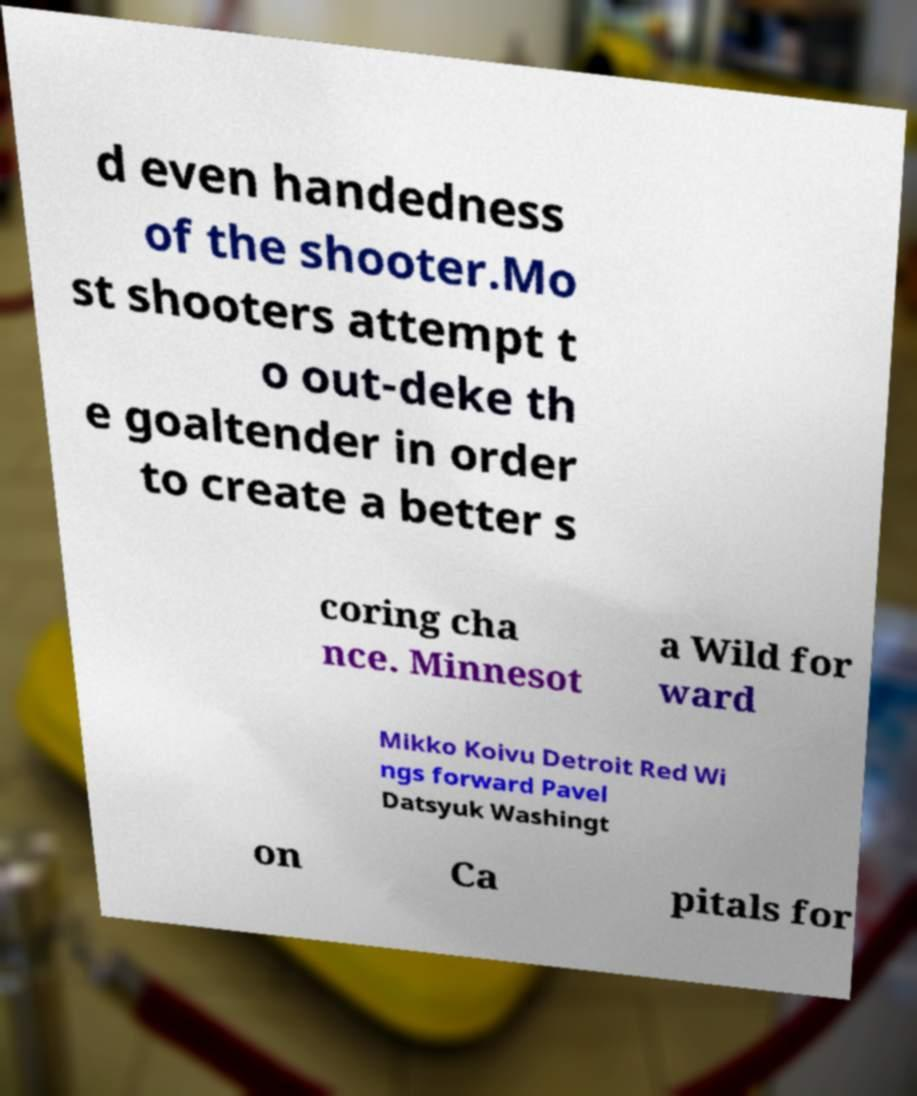What messages or text are displayed in this image? I need them in a readable, typed format. d even handedness of the shooter.Mo st shooters attempt t o out-deke th e goaltender in order to create a better s coring cha nce. Minnesot a Wild for ward Mikko Koivu Detroit Red Wi ngs forward Pavel Datsyuk Washingt on Ca pitals for 